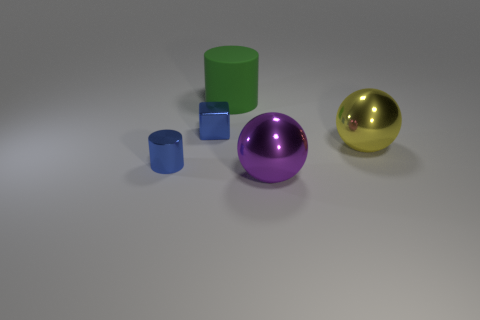Add 1 purple shiny things. How many objects exist? 6 Subtract all balls. How many objects are left? 3 Add 3 big purple metallic things. How many big purple metallic things exist? 4 Subtract 1 purple spheres. How many objects are left? 4 Subtract all rubber things. Subtract all small cylinders. How many objects are left? 3 Add 3 small blue cylinders. How many small blue cylinders are left? 4 